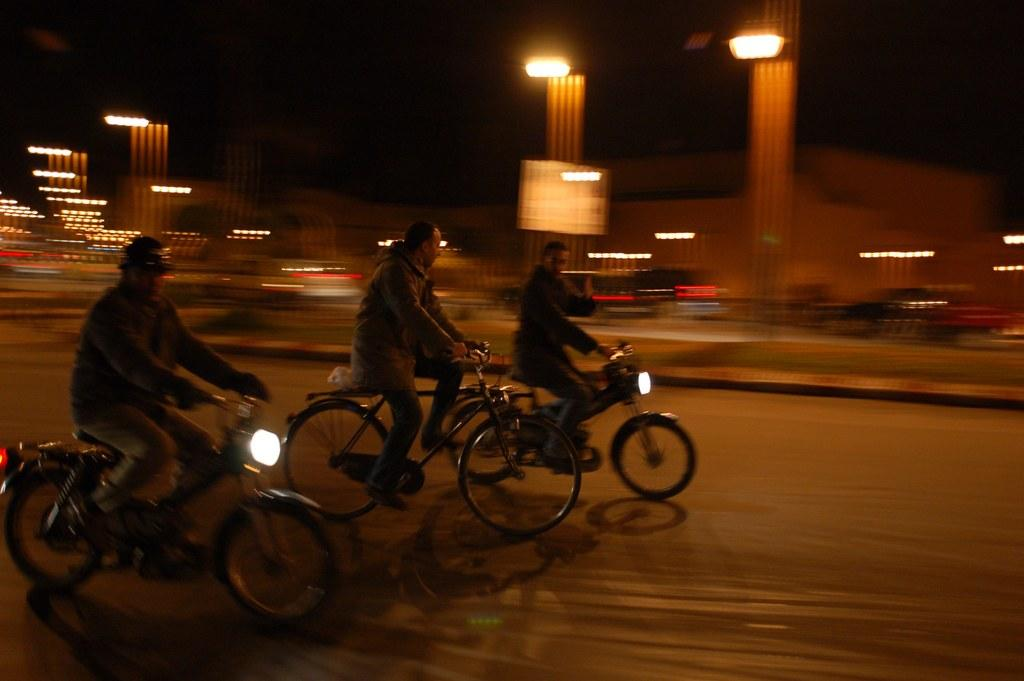How many people are in the image? There are three persons in the image. What are the persons doing in the image? The persons are sitting and riding bicycles. What can be seen in the background of the image? There is a road in the image. What else is visible in the image besides the road? There are lights visible in the image. What type of fruit is being used to pump air into the bicycle tires in the image? There is no fruit or pump present in the image; the persons are simply riding bicycles. Can you tell me how many yaks are visible in the image? There are no yaks present in the image. 